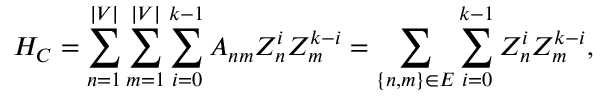<formula> <loc_0><loc_0><loc_500><loc_500>H _ { C } = \sum _ { n = 1 } ^ { | V | } \sum _ { m = 1 } ^ { | V | } \sum _ { i = 0 } ^ { k - 1 } A _ { n m } Z _ { n } ^ { i } Z _ { m } ^ { k - i } = \sum _ { \left \{ n , m \right \} \in E } \sum _ { i = 0 } ^ { k - 1 } Z _ { n } ^ { i } Z _ { m } ^ { k - i } ,</formula> 